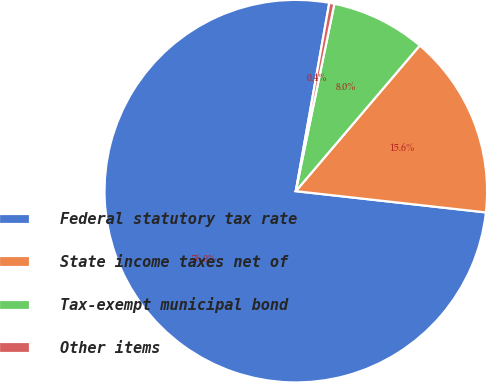Convert chart to OTSL. <chart><loc_0><loc_0><loc_500><loc_500><pie_chart><fcel>Federal statutory tax rate<fcel>State income taxes net of<fcel>Tax-exempt municipal bond<fcel>Other items<nl><fcel>76.02%<fcel>15.55%<fcel>7.99%<fcel>0.43%<nl></chart> 